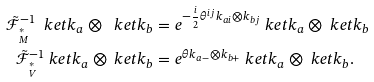Convert formula to latex. <formula><loc_0><loc_0><loc_500><loc_500>\tilde { \mathcal { F } } _ { ^ { * } _ { M } } ^ { - 1 } \ k e t { k _ { a } } \otimes \ k e t { k _ { b } } & = e ^ { - \frac { i } { 2 } \theta ^ { i j } k _ { a i } \otimes k _ { b j } } \ k e t { k _ { a } } \otimes \ k e t { k _ { b } } \\ \tilde { \mathcal { F } } _ { ^ { * } _ { V } } ^ { - 1 } \ k e t { k _ { a } } \otimes \ k e t { k _ { b } } & = e ^ { \theta k _ { a - } \otimes k _ { b + } } \ k e t { k _ { a } } \otimes \ k e t { k _ { b } } .</formula> 